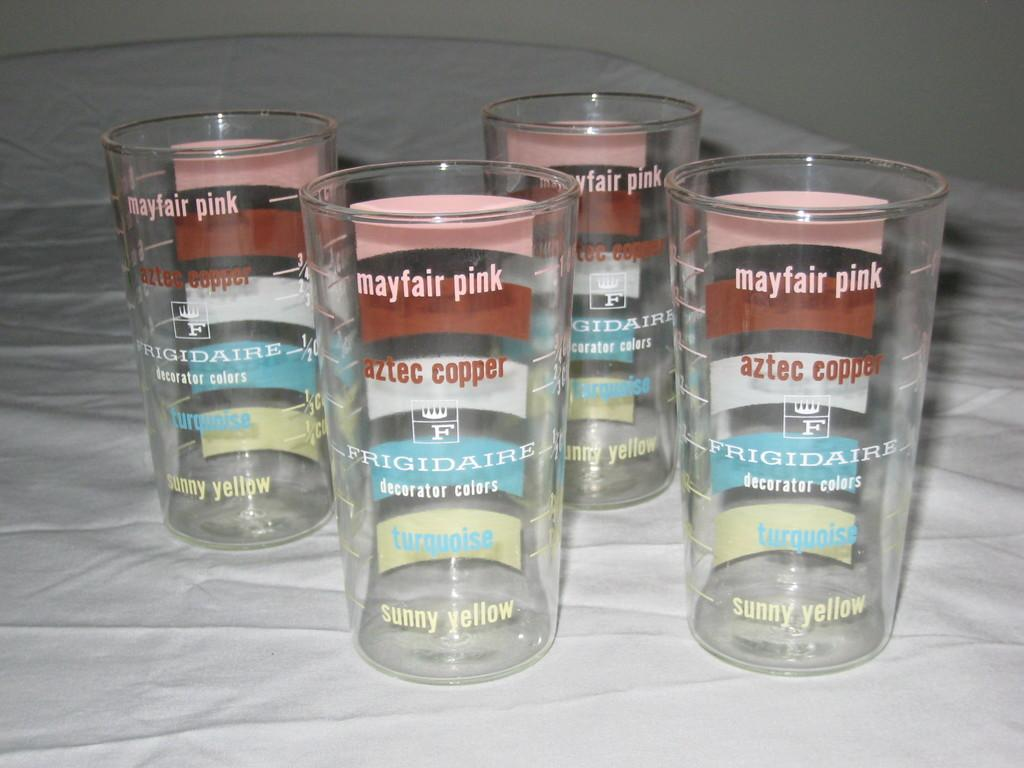<image>
Relay a brief, clear account of the picture shown. Four glasses display the different colors that Frigidaires are available in. 